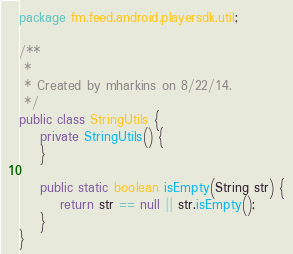<code> <loc_0><loc_0><loc_500><loc_500><_Java_>package fm.feed.android.playersdk.util;

/**
 *
 * Created by mharkins on 8/22/14.
 */
public class StringUtils {
    private StringUtils() {
    }

    public static boolean isEmpty(String str) {
        return str == null || str.isEmpty();
    }
}
</code> 